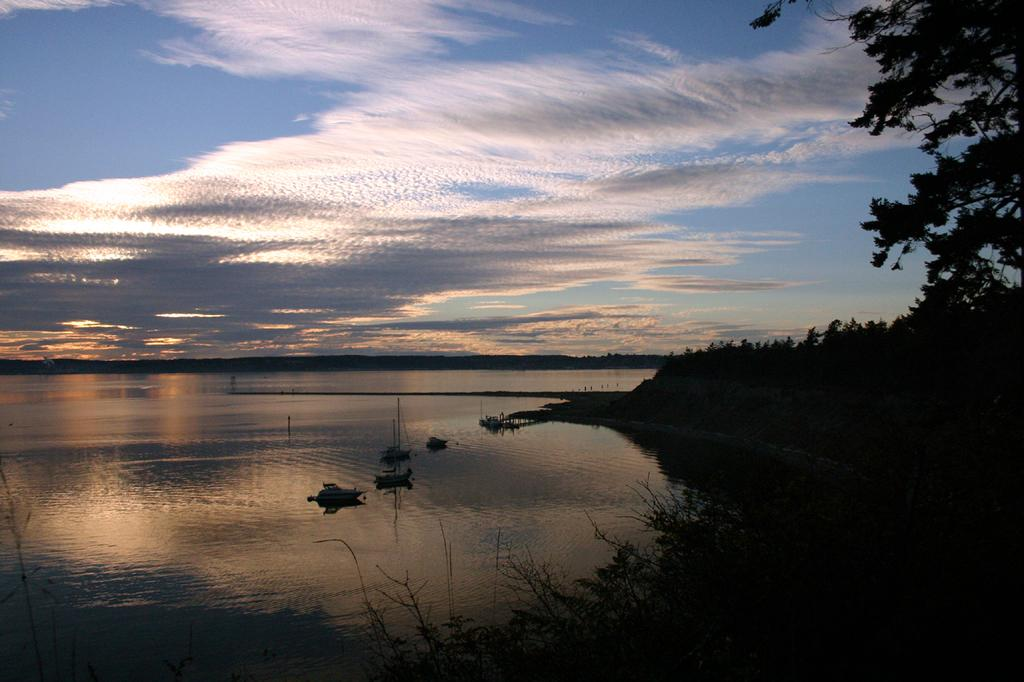What is on the water in the image? There are boats on the water in the image. What can be seen on the right side of the image? There are trees on the right side of the image. What is visible in the sky in the image? Clouds are visible in the image. How many arches can be seen in the image? There are no arches present in the image. What type of slave is depicted in the image? There is no depiction of a slave in the image; it features boats on the water, trees, and clouds. 